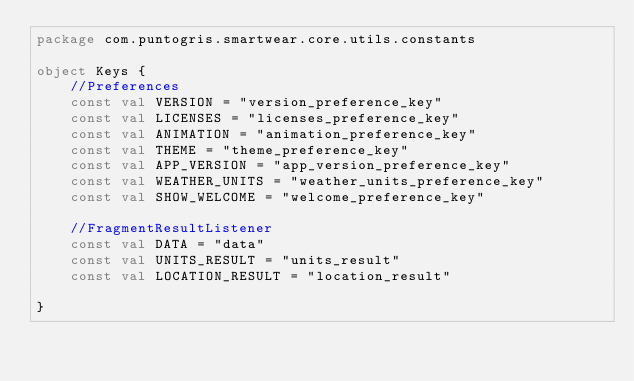Convert code to text. <code><loc_0><loc_0><loc_500><loc_500><_Kotlin_>package com.puntogris.smartwear.core.utils.constants

object Keys {
    //Preferences
    const val VERSION = "version_preference_key"
    const val LICENSES = "licenses_preference_key"
    const val ANIMATION = "animation_preference_key"
    const val THEME = "theme_preference_key"
    const val APP_VERSION = "app_version_preference_key"
    const val WEATHER_UNITS = "weather_units_preference_key"
    const val SHOW_WELCOME = "welcome_preference_key"

    //FragmentResultListener
    const val DATA = "data"
    const val UNITS_RESULT = "units_result"
    const val LOCATION_RESULT = "location_result"

}</code> 